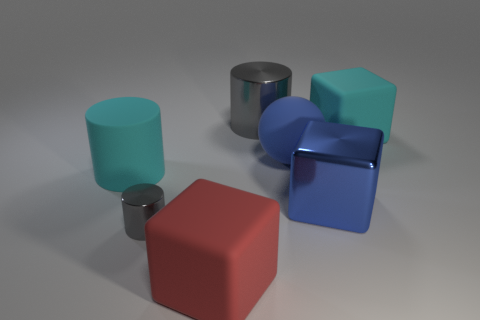What is the shape of the shiny thing that is the same color as the tiny metallic cylinder?
Offer a terse response. Cylinder. There is a big cylinder on the left side of the red matte cube; is its color the same as the rubber block that is on the right side of the red block?
Your answer should be compact. Yes. Are there any large matte things of the same color as the large matte cylinder?
Ensure brevity in your answer.  Yes. There is a matte cube on the right side of the red cube; is it the same size as the gray cylinder on the left side of the big red object?
Keep it short and to the point. No. The shiny thing that is the same color as the big shiny cylinder is what size?
Offer a very short reply. Small. How many other things are the same size as the rubber sphere?
Provide a short and direct response. 5. What color is the big metal object that is behind the cyan rubber cylinder?
Offer a very short reply. Gray. Is the size of the red rubber object the same as the cyan cylinder?
Offer a very short reply. Yes. There is a gray cylinder behind the rubber cube that is behind the red thing; what is it made of?
Your response must be concise. Metal. How many big rubber cylinders are the same color as the large ball?
Give a very brief answer. 0. 